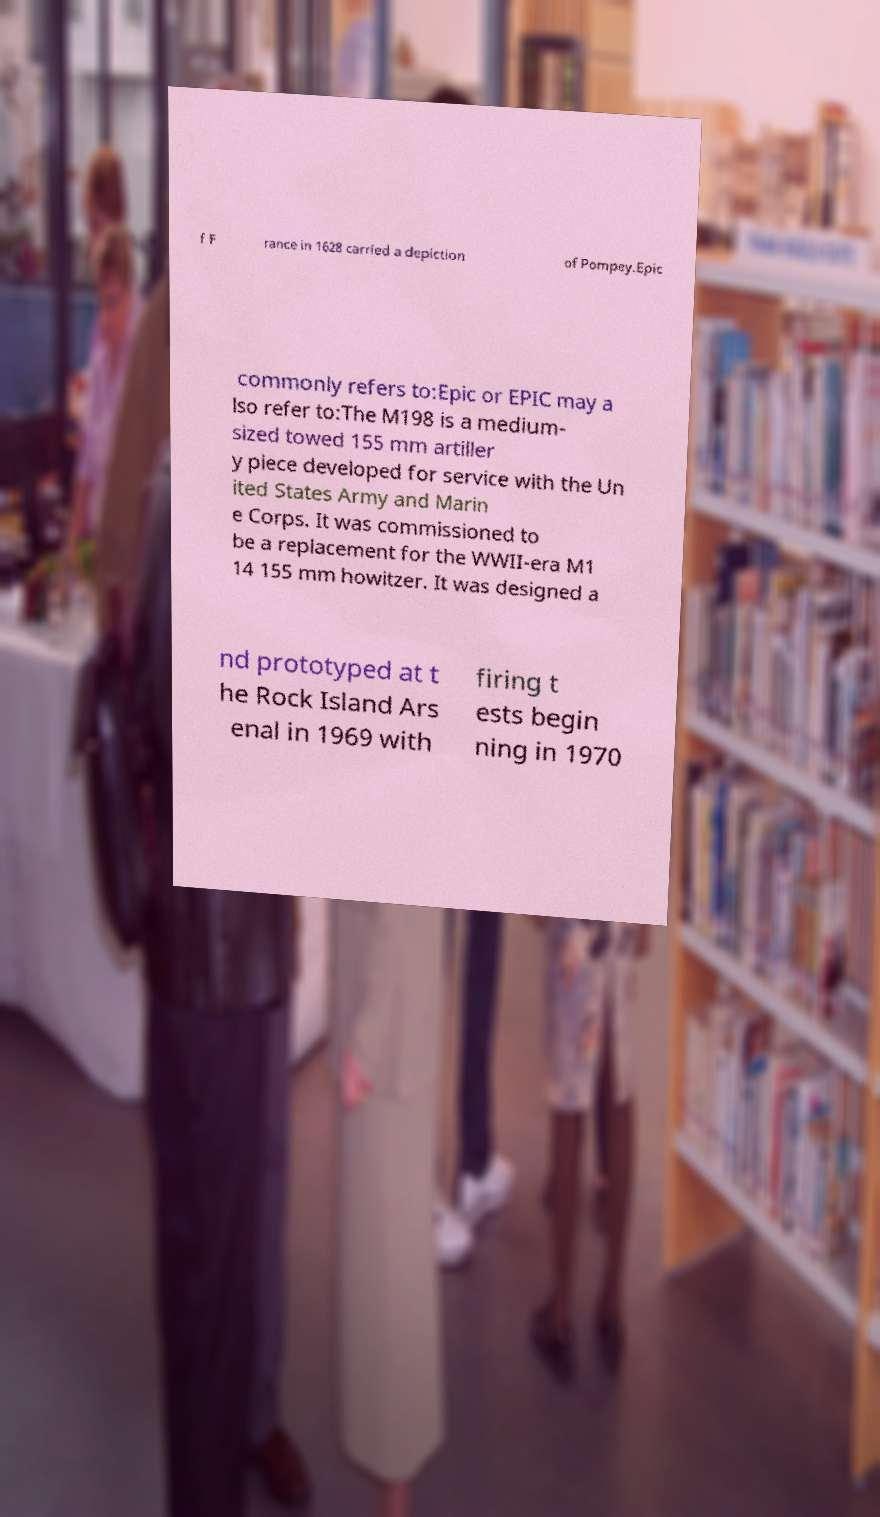Can you accurately transcribe the text from the provided image for me? f F rance in 1628 carried a depiction of Pompey.Epic commonly refers to:Epic or EPIC may a lso refer to:The M198 is a medium- sized towed 155 mm artiller y piece developed for service with the Un ited States Army and Marin e Corps. It was commissioned to be a replacement for the WWII-era M1 14 155 mm howitzer. It was designed a nd prototyped at t he Rock Island Ars enal in 1969 with firing t ests begin ning in 1970 